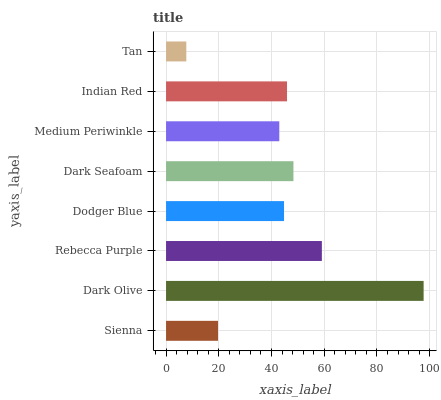Is Tan the minimum?
Answer yes or no. Yes. Is Dark Olive the maximum?
Answer yes or no. Yes. Is Rebecca Purple the minimum?
Answer yes or no. No. Is Rebecca Purple the maximum?
Answer yes or no. No. Is Dark Olive greater than Rebecca Purple?
Answer yes or no. Yes. Is Rebecca Purple less than Dark Olive?
Answer yes or no. Yes. Is Rebecca Purple greater than Dark Olive?
Answer yes or no. No. Is Dark Olive less than Rebecca Purple?
Answer yes or no. No. Is Indian Red the high median?
Answer yes or no. Yes. Is Dodger Blue the low median?
Answer yes or no. Yes. Is Rebecca Purple the high median?
Answer yes or no. No. Is Dark Seafoam the low median?
Answer yes or no. No. 